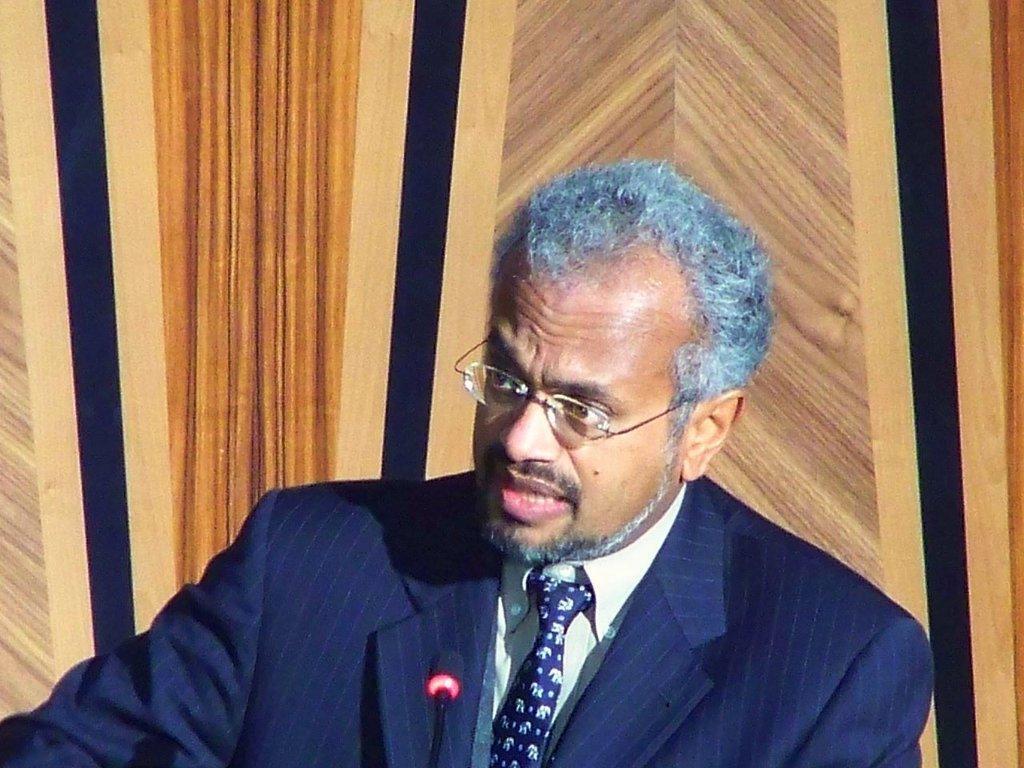Please provide a concise description of this image. Here we can see a man talking on the mike. He is in a suit and he has spectacles. 